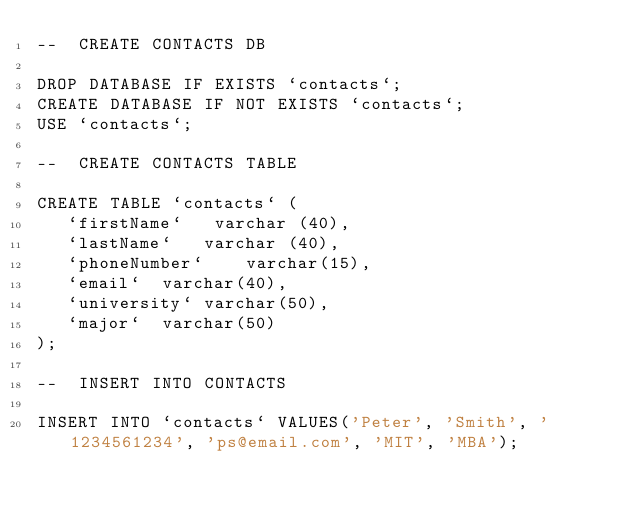Convert code to text. <code><loc_0><loc_0><loc_500><loc_500><_SQL_>--  CREATE CONTACTS DB

DROP DATABASE IF EXISTS `contacts`;
CREATE DATABASE IF NOT EXISTS `contacts`;
USE `contacts`;

--  CREATE CONTACTS TABLE

CREATE TABLE `contacts` (
   `firstName`   varchar (40),
   `lastName`	varchar (40),
   `phoneNumber`	varchar(15),
   `email`	varchar(40),
   `university`	varchar(50),
   `major`	varchar(50)
);

--  INSERT INTO CONTACTS

INSERT INTO `contacts` VALUES('Peter', 'Smith', '1234561234', 'ps@email.com', 'MIT', 'MBA');
</code> 